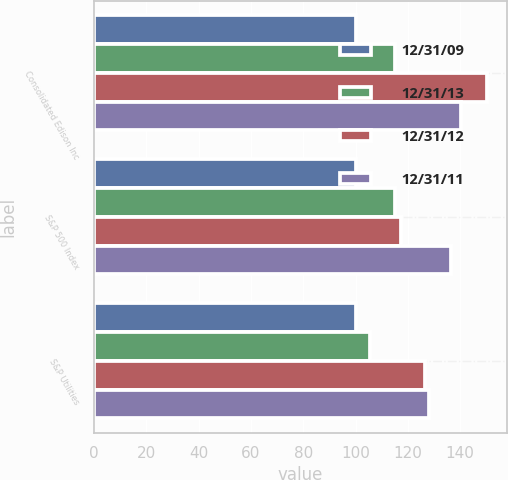<chart> <loc_0><loc_0><loc_500><loc_500><stacked_bar_chart><ecel><fcel>Consolidated Edison Inc<fcel>S&P 500 Index<fcel>S&P Utilities<nl><fcel>12/31/09<fcel>100<fcel>100<fcel>100<nl><fcel>12/31/13<fcel>114.92<fcel>115.06<fcel>105.46<nl><fcel>12/31/12<fcel>150.33<fcel>117.49<fcel>126.46<nl><fcel>12/31/11<fcel>140.22<fcel>136.3<fcel>128.09<nl></chart> 